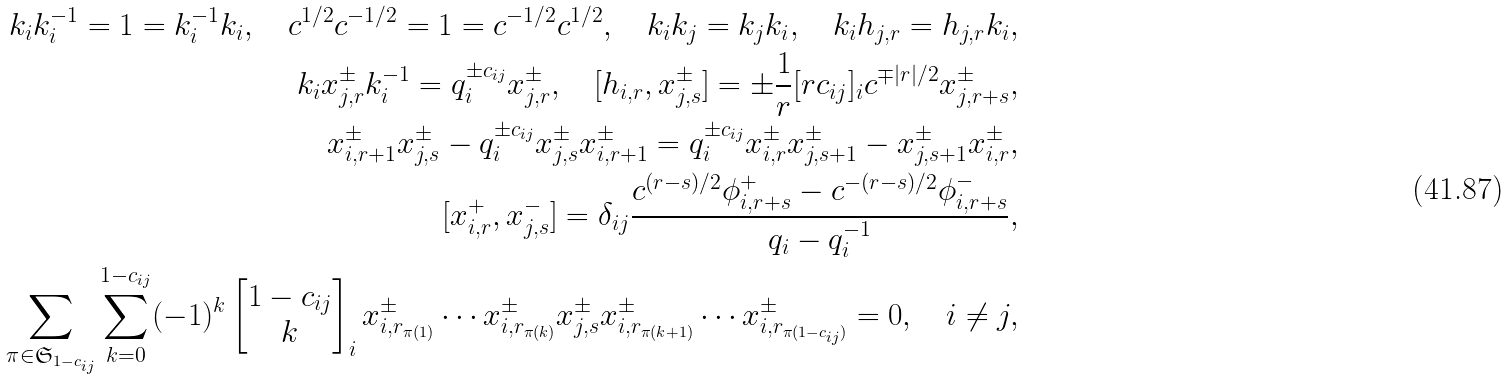<formula> <loc_0><loc_0><loc_500><loc_500>k _ { i } k _ { i } ^ { - 1 } = 1 = k _ { i } ^ { - 1 } k _ { i } , \quad c ^ { 1 / 2 } c ^ { - 1 / 2 } = 1 = c ^ { - 1 / 2 } c ^ { 1 / 2 } , \quad k _ { i } k _ { j } = k _ { j } k _ { i } , \quad k _ { i } h _ { j , r } = h _ { j , r } k _ { i } , \\ k _ { i } x ^ { \pm } _ { j , r } k _ { i } ^ { - 1 } = q _ { i } ^ { \pm c _ { i j } } x ^ { \pm } _ { j , r } , \quad [ h _ { i , r } , x ^ { \pm } _ { j , s } ] = \pm \frac { 1 } { r } [ r c _ { i j } ] _ { i } c ^ { \mp | r | / 2 } x ^ { \pm } _ { j , r + s } , \\ x ^ { \pm } _ { i , r + 1 } x ^ { \pm } _ { j , s } - q _ { i } ^ { \pm c _ { i j } } x ^ { \pm } _ { j , s } x ^ { \pm } _ { i , r + 1 } = q _ { i } ^ { \pm c _ { i j } } x ^ { \pm } _ { i , r } x ^ { \pm } _ { j , s + 1 } - x ^ { \pm } _ { j , s + 1 } x ^ { \pm } _ { i , r } , \\ [ x ^ { + } _ { i , r } , x ^ { - } _ { j , s } ] = \delta _ { i j } \frac { c ^ { ( r - s ) / 2 } \phi ^ { + } _ { i , r + s } - c ^ { - ( r - s ) / 2 } \phi ^ { - } _ { i , r + s } } { q _ { i } - q _ { i } ^ { - 1 } } , \\ \sum _ { \pi \in \mathfrak { S } _ { 1 - c _ { i j } } } \sum ^ { 1 - c _ { i j } } _ { k = 0 } ( - 1 ) ^ { k } \left [ \begin{matrix} 1 - c _ { i j } \\ k \end{matrix} \right ] _ { i } x ^ { \pm } _ { i , r _ { \pi ( 1 ) } } \cdots x ^ { \pm } _ { i , r _ { \pi ( k ) } } x ^ { \pm } _ { j , s } x ^ { \pm } _ { i , r _ { \pi ( k + 1 ) } } \cdots x ^ { \pm } _ { i , r _ { \pi ( 1 - c _ { i j } ) } } = 0 , \quad i \neq j ,</formula> 